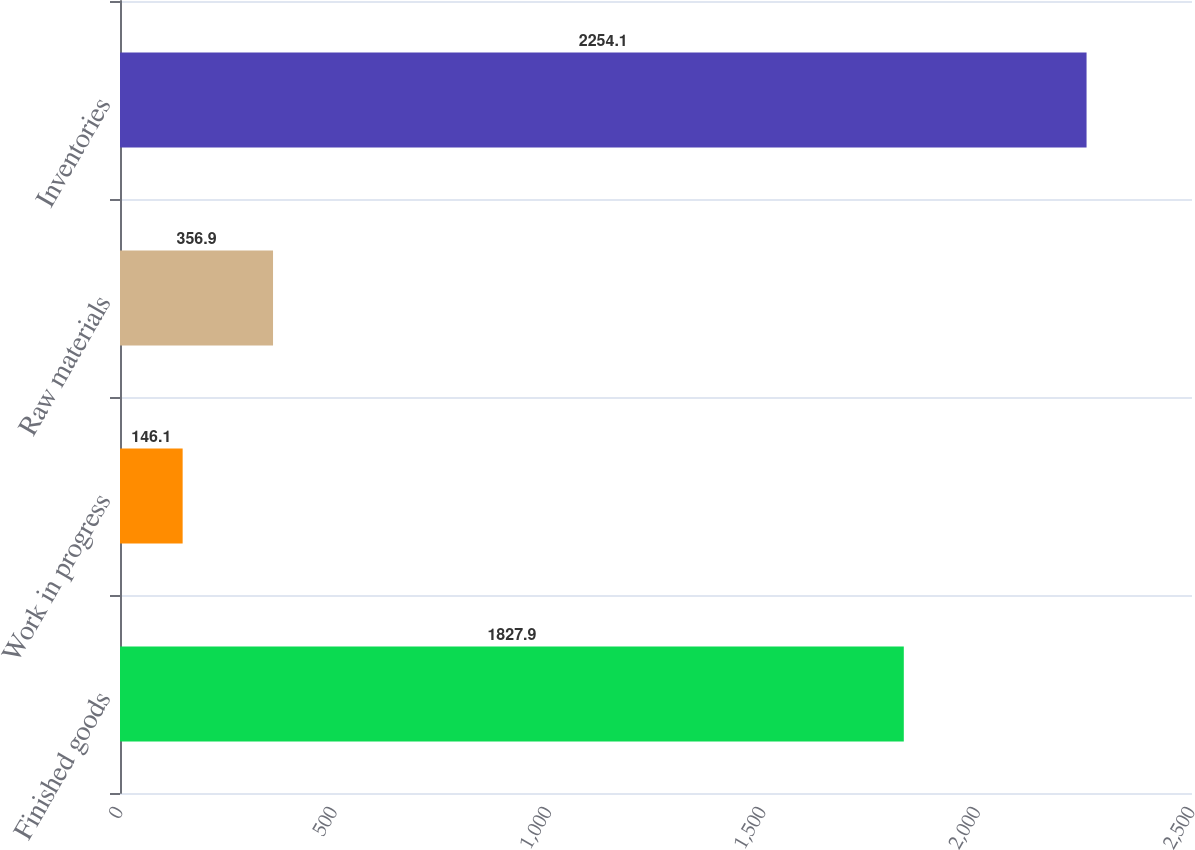<chart> <loc_0><loc_0><loc_500><loc_500><bar_chart><fcel>Finished goods<fcel>Work in progress<fcel>Raw materials<fcel>Inventories<nl><fcel>1827.9<fcel>146.1<fcel>356.9<fcel>2254.1<nl></chart> 